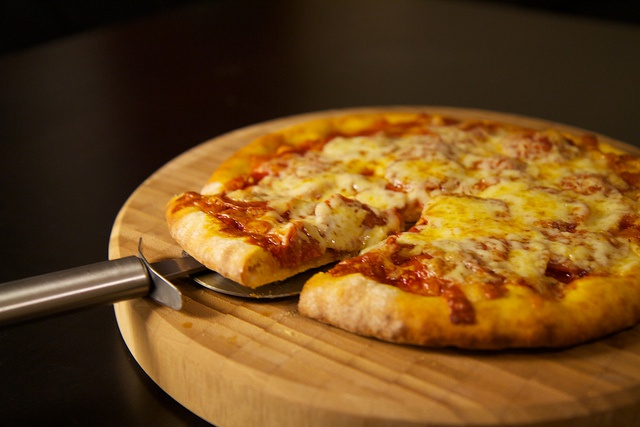Describe the objects in this image and their specific colors. I can see dining table in black, olive, gray, and tan tones, pizza in black, red, orange, tan, and maroon tones, and knife in black, maroon, and gray tones in this image. 